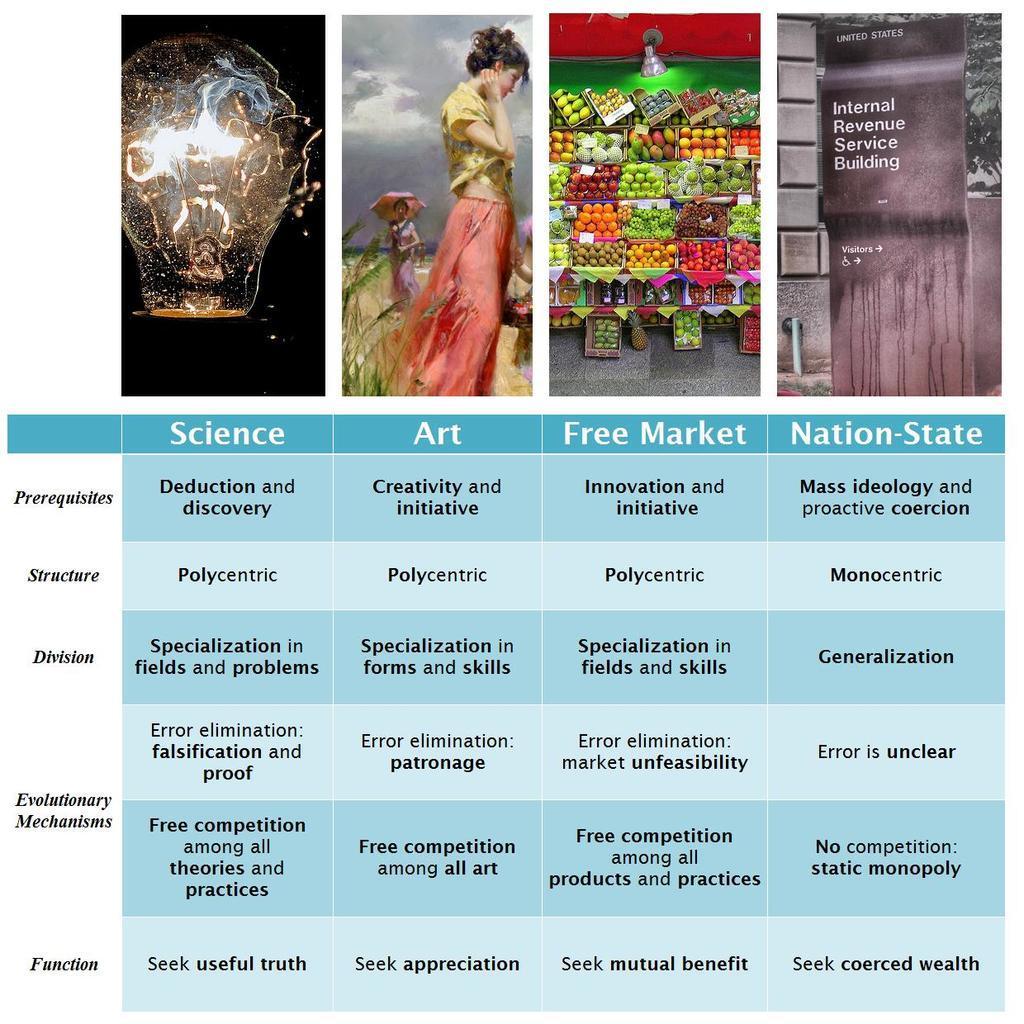Can you describe this image briefly? In this image, we can see four pictures and some text. In the first picture, we can see a bulb. In the second picture we can see a person standing and wearing clothes. In the third picture, there are some fruits. In the fourth picture, there is a wall. 